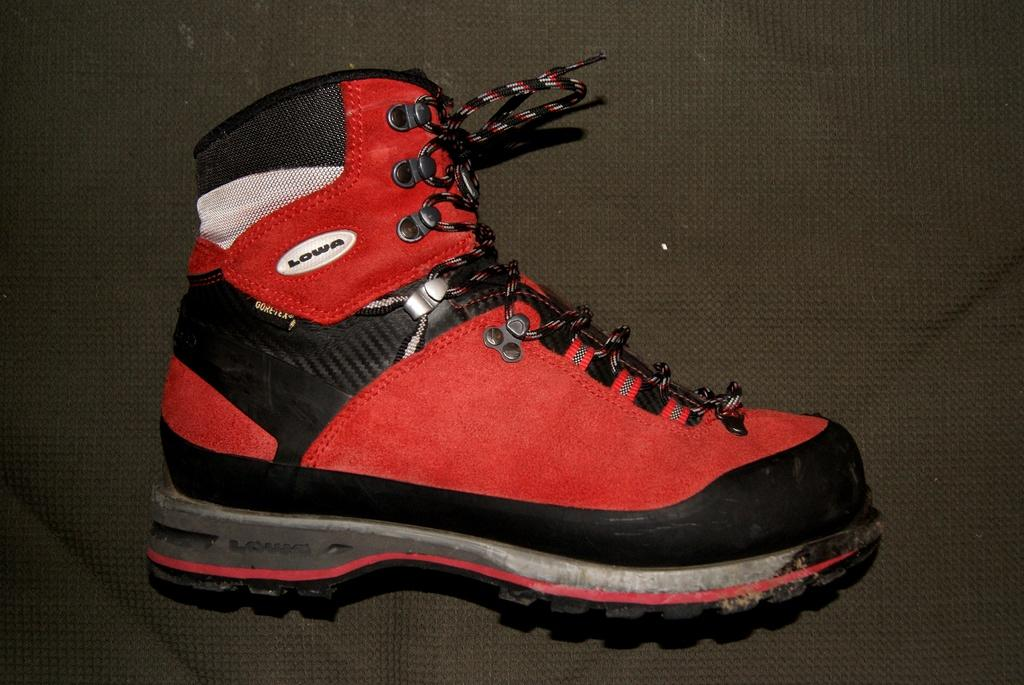What object is the main subject of the image? There is a shoe in the image. What colors can be seen on the shoe? The shoe has red and black colors. What color is the background of the image? The background of the image is black. How does the zephyr affect the shoe in the image? There is no zephyr present in the image, so it cannot affect the shoe. 